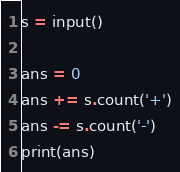Convert code to text. <code><loc_0><loc_0><loc_500><loc_500><_Python_>s = input()

ans = 0
ans += s.count('+')
ans -= s.count('-')
print(ans)</code> 